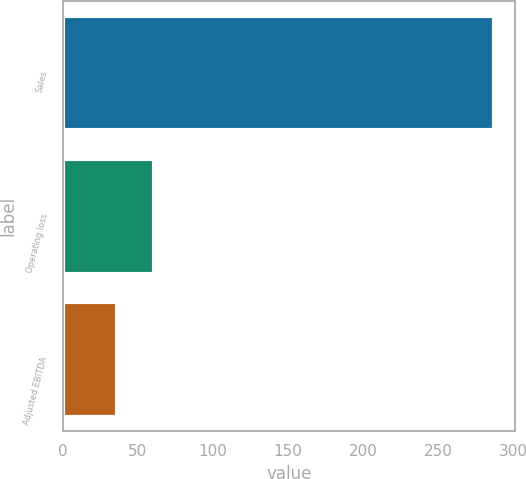<chart> <loc_0><loc_0><loc_500><loc_500><bar_chart><fcel>Sales<fcel>Operating loss<fcel>Adjusted EBITDA<nl><fcel>286.8<fcel>60.99<fcel>35.9<nl></chart> 